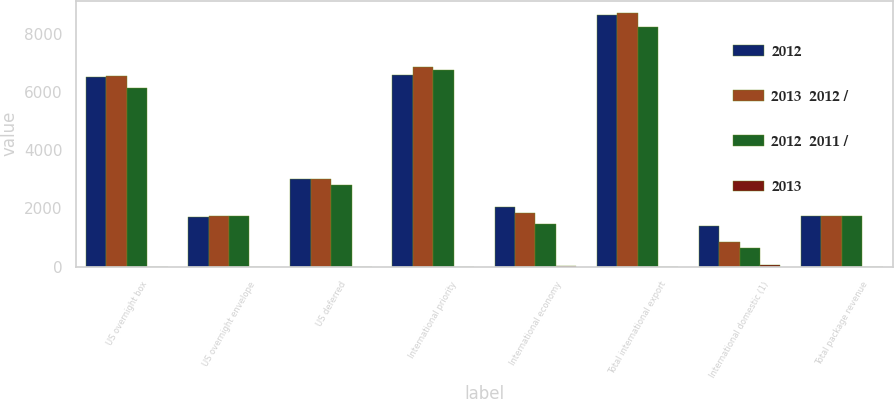<chart> <loc_0><loc_0><loc_500><loc_500><stacked_bar_chart><ecel><fcel>US overnight box<fcel>US overnight envelope<fcel>US deferred<fcel>International priority<fcel>International economy<fcel>Total international export<fcel>International domestic (1)<fcel>Total package revenue<nl><fcel>2012<fcel>6513<fcel>1705<fcel>3020<fcel>6586<fcel>2046<fcel>8632<fcel>1398<fcel>1747<nl><fcel>2013  2012 /<fcel>6546<fcel>1747<fcel>3001<fcel>6849<fcel>1859<fcel>8708<fcel>853<fcel>1747<nl><fcel>2012  2011 /<fcel>6128<fcel>1736<fcel>2805<fcel>6760<fcel>1468<fcel>8228<fcel>653<fcel>1747<nl><fcel>2013<fcel>1<fcel>2<fcel>1<fcel>4<fcel>10<fcel>1<fcel>64<fcel>2<nl></chart> 